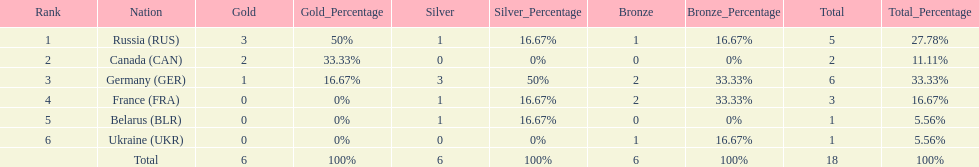Which country won the same amount of silver medals as the french and the russians? Belarus. 